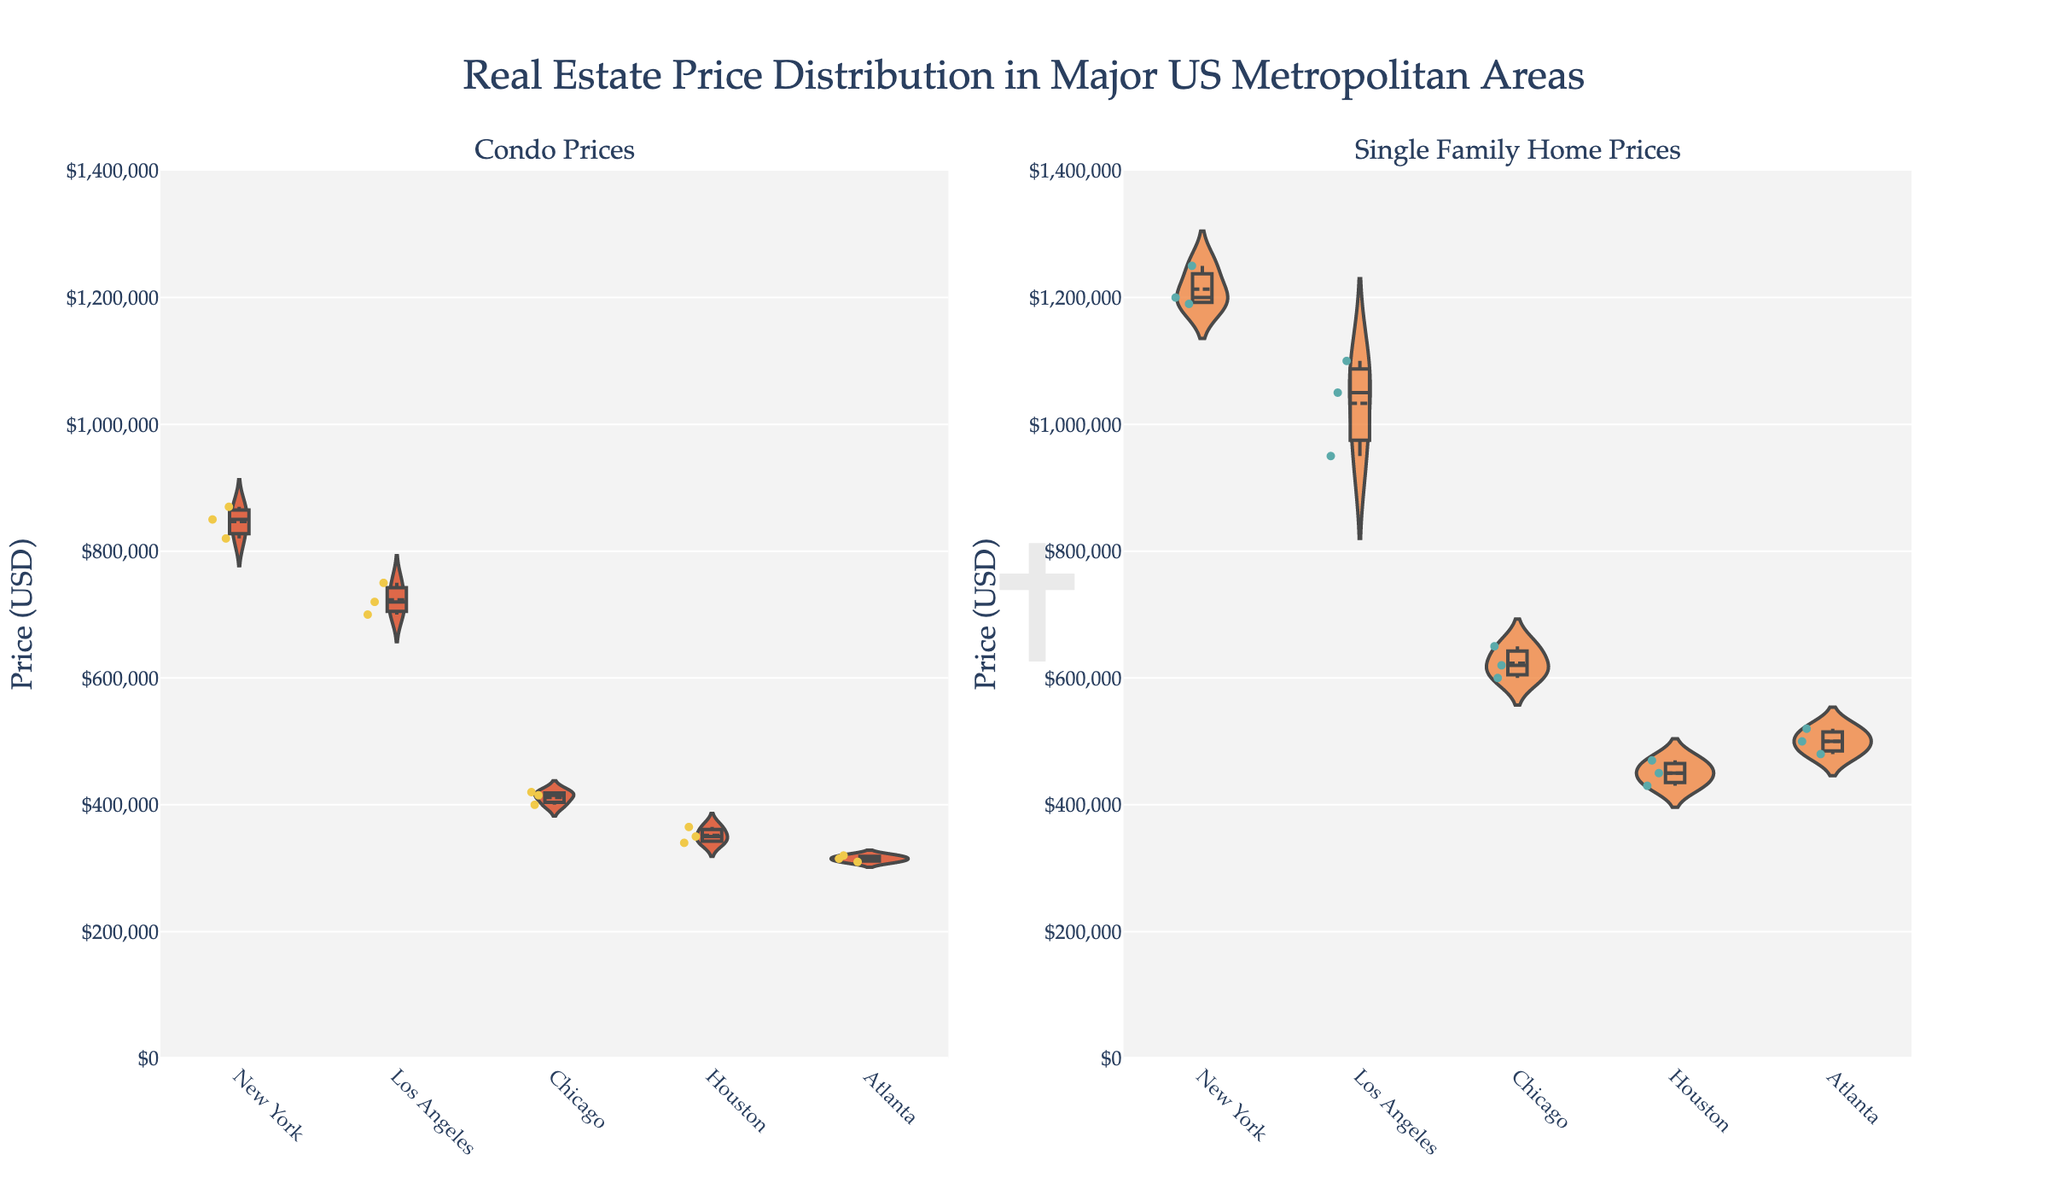How are the prices of condos distributed across the different metropolitan areas in the US? Look at the left subplot titled "Condo Prices" which displays the violin plots for condo prices in New York, Los Angeles, Chicago, Houston, and Atlanta. The widths of the violins and enclosed box plots illustrate the price distributions.
Answer: Prices vary widely across different areas Which metropolitan area has the highest median price for single-family homes? Check the median lines visible inside the violin plots in the "Single Family Home Prices" subplot. Observe which city's median line is the highest.
Answer: New York What is the price range for condos in Chicago based on the violin plot? Examine the left subplot and identify the furthest points of the violin plot that mark the lowest and highest prices for Chicago condos, considering the whiskers of the box plot.
Answer: $400,000 to $420,000 Compare the price distributions of single-family homes in Los Angeles and Atlanta. Which one shows greater price variability? In the "Single Family Home Prices" subplot, compare the widths and spread of the violin plots for Los Angeles and Atlanta. The wider plot with longer whiskers indicates greater variability.
Answer: Los Angeles Are the mean prices for single-family homes higher than condo prices across all metropolitan areas? Look at the mean lines within the violin plots for both property types in each subplot and compare which property type has higher mean lines consistently.
Answer: Yes How do condo prices in Houston compare to single-family home prices in the same city in terms of variability? Compare the widths and spread of the violin plots for condos and single-family homes in Houston across both subplots. Wider plots indicate higher variability.
Answer: Single-family homes have greater variability What is the title of the entire figure? The title is located at the top center of the figure.
Answer: Real Estate Price Distribution in Major US Metropolitan Areas Which city has the lowest maximum price for single-family homes? Look at the maximum points (top whiskers) in the "Single Family Home Prices" subplot and identify the city with the lowest one.
Answer: Houston What is the primary color used for the violin plots representing condos? Observe the fill color of the violins in the left subplot.
Answer: Red (or a similar hue inspired by stained glass) How is the general trend of property prices between condos and single-family homes across metropolitan areas? By comparing both subplots, generally, the single-family homes are priced higher than the condos across all the areas depicted.
Answer: Single-family homes are generally more expensive 